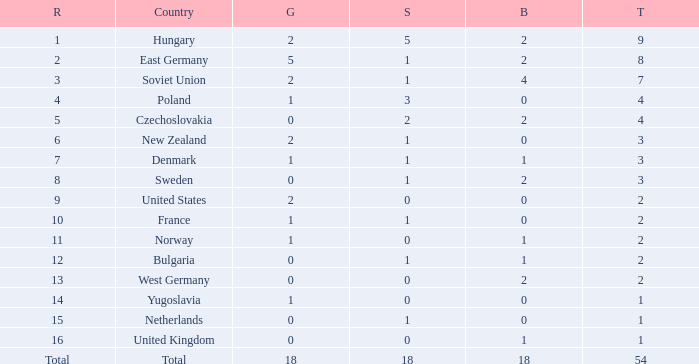Parse the table in full. {'header': ['R', 'Country', 'G', 'S', 'B', 'T'], 'rows': [['1', 'Hungary', '2', '5', '2', '9'], ['2', 'East Germany', '5', '1', '2', '8'], ['3', 'Soviet Union', '2', '1', '4', '7'], ['4', 'Poland', '1', '3', '0', '4'], ['5', 'Czechoslovakia', '0', '2', '2', '4'], ['6', 'New Zealand', '2', '1', '0', '3'], ['7', 'Denmark', '1', '1', '1', '3'], ['8', 'Sweden', '0', '1', '2', '3'], ['9', 'United States', '2', '0', '0', '2'], ['10', 'France', '1', '1', '0', '2'], ['11', 'Norway', '1', '0', '1', '2'], ['12', 'Bulgaria', '0', '1', '1', '2'], ['13', 'West Germany', '0', '0', '2', '2'], ['14', 'Yugoslavia', '1', '0', '0', '1'], ['15', 'Netherlands', '0', '1', '0', '1'], ['16', 'United Kingdom', '0', '0', '1', '1'], ['Total', 'Total', '18', '18', '18', '54']]} What is the lowest total for those receiving less than 18 but more than 14? 1.0. 